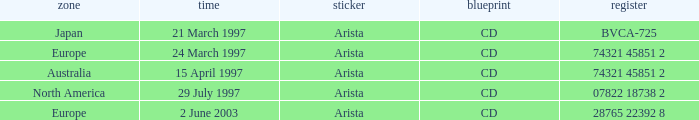What tag is assigned to the australian zone? Arista. 